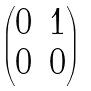<formula> <loc_0><loc_0><loc_500><loc_500>\begin{pmatrix} 0 & 1 \\ 0 & 0 \end{pmatrix}</formula> 